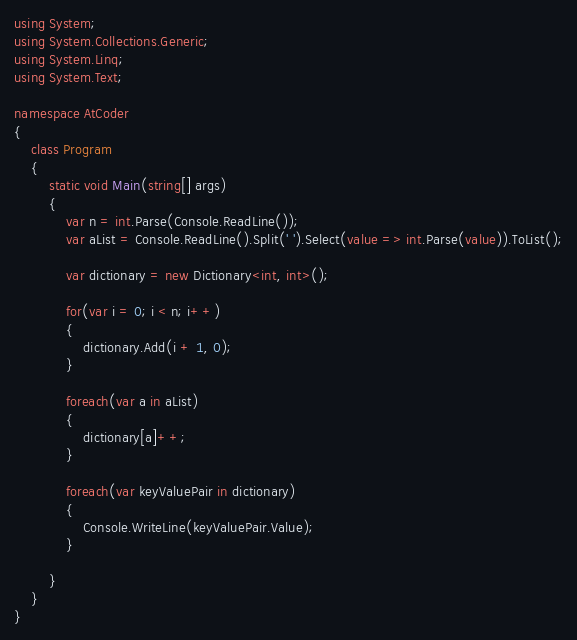Convert code to text. <code><loc_0><loc_0><loc_500><loc_500><_C#_>using System;
using System.Collections.Generic;
using System.Linq;
using System.Text;

namespace AtCoder
{
	class Program
	{
		static void Main(string[] args)
		{
			var n = int.Parse(Console.ReadLine());
			var aList = Console.ReadLine().Split(' ').Select(value => int.Parse(value)).ToList();

			var dictionary = new Dictionary<int, int>();

			for(var i = 0; i < n; i++)
			{
				dictionary.Add(i + 1, 0);
			}

			foreach(var a in aList)
			{
				dictionary[a]++;
			}

			foreach(var keyValuePair in dictionary)
			{
				Console.WriteLine(keyValuePair.Value);
			}

		}
	}
}
</code> 